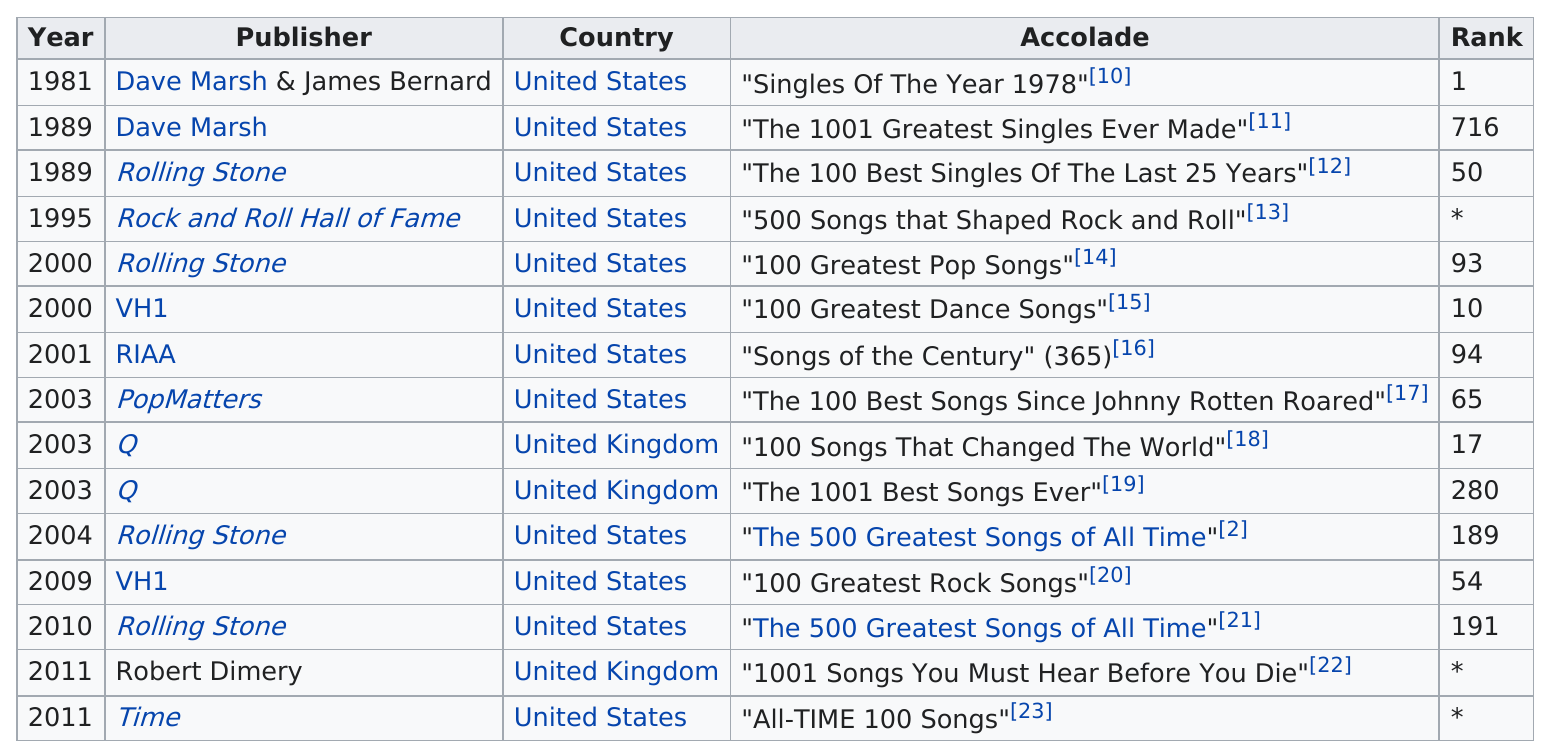Outline some significant characteristics in this image. The song 'Stayin' Alive' received the most accolades from Rolling Stone. 